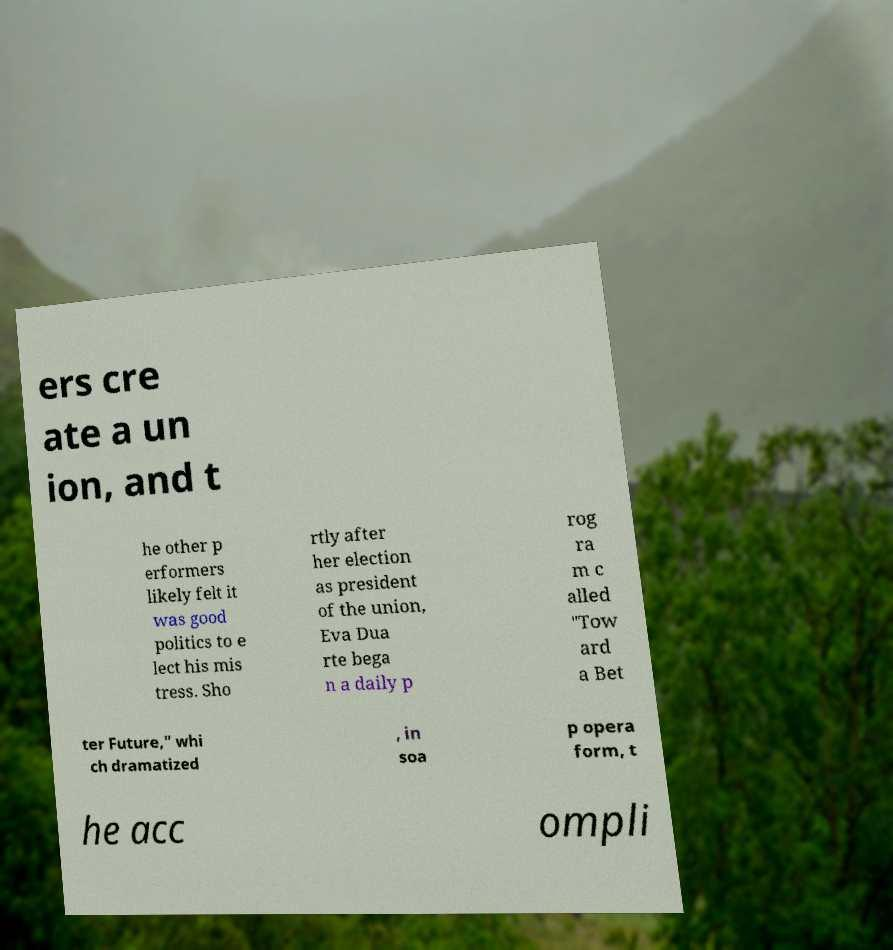Can you read and provide the text displayed in the image?This photo seems to have some interesting text. Can you extract and type it out for me? ers cre ate a un ion, and t he other p erformers likely felt it was good politics to e lect his mis tress. Sho rtly after her election as president of the union, Eva Dua rte bega n a daily p rog ra m c alled "Tow ard a Bet ter Future," whi ch dramatized , in soa p opera form, t he acc ompli 